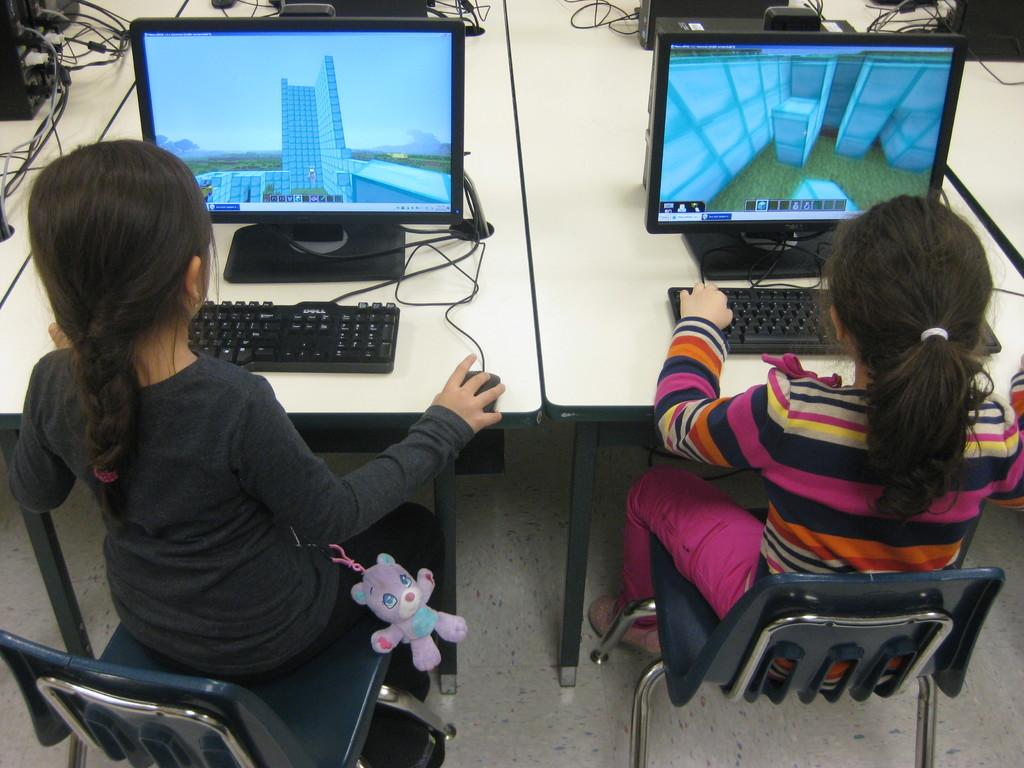How many women are in the image? There are two women in the image. What are the women doing in the image? The women are sitting on a chair. What electronic devices can be seen in the image? There is a computer, a laptop, a mouse, and a keyboard in the image. What other objects are present on the table? There are other objects on the table, but their specific details are not mentioned in the facts. Is there a toy in the image? Yes, there is a toy in the image. What type of spoon is being used to play with the duck in the sand in the image? There is no spoon, duck, or sand present in the image. 